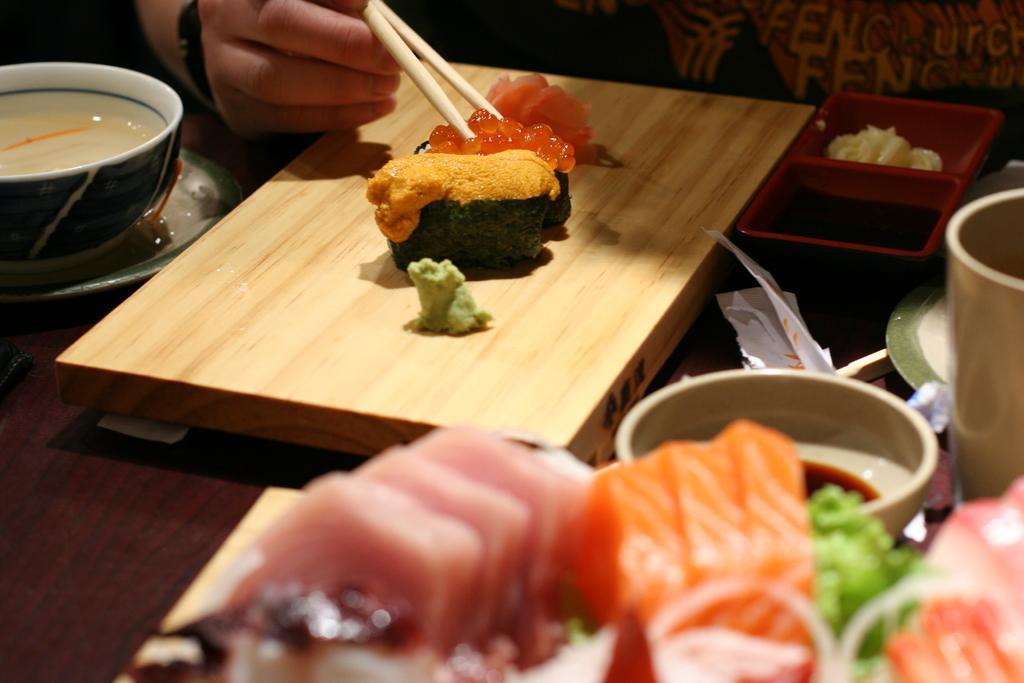Can you describe this image briefly? There is a person holding sticks. We can see bowl,plates,board,food,container,paper on the table. 